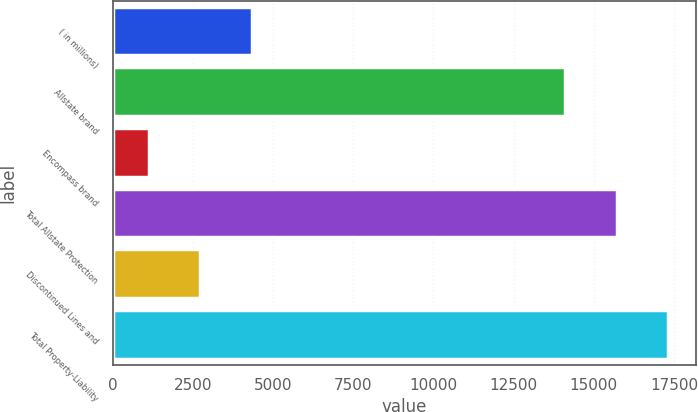Convert chart to OTSL. <chart><loc_0><loc_0><loc_500><loc_500><bar_chart><fcel>( in millions)<fcel>Allstate brand<fcel>Encompass brand<fcel>Total Allstate Protection<fcel>Discontinued Lines and<fcel>Total Property-Liability<nl><fcel>4342.8<fcel>14118<fcel>1133<fcel>15722.9<fcel>2737.9<fcel>17327.8<nl></chart> 